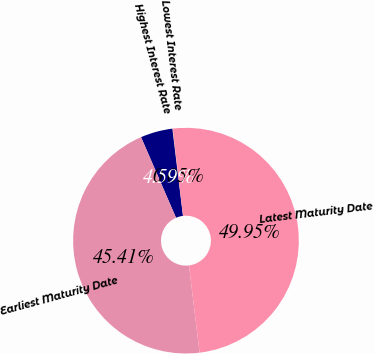Convert chart. <chart><loc_0><loc_0><loc_500><loc_500><pie_chart><fcel>Lowest Interest Rate<fcel>Highest Interest Rate<fcel>Earliest Maturity Date<fcel>Latest Maturity Date<nl><fcel>0.05%<fcel>4.59%<fcel>45.41%<fcel>49.95%<nl></chart> 